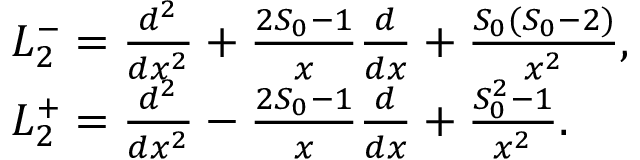Convert formula to latex. <formula><loc_0><loc_0><loc_500><loc_500>\begin{array} { r l } & { L _ { 2 } ^ { - } = \frac { d ^ { 2 } } { d x ^ { 2 } } + \frac { 2 S _ { 0 } - 1 } { x } \frac { d } { d x } + \frac { S _ { 0 } ( S _ { 0 } - 2 ) } { x ^ { 2 } } , } \\ & { L _ { 2 } ^ { + } = \frac { d ^ { 2 } } { d x ^ { 2 } } - \frac { 2 S _ { 0 } - 1 } { x } \frac { d } { d x } + \frac { S _ { 0 } ^ { 2 } - 1 } { x ^ { 2 } } . } \end{array}</formula> 